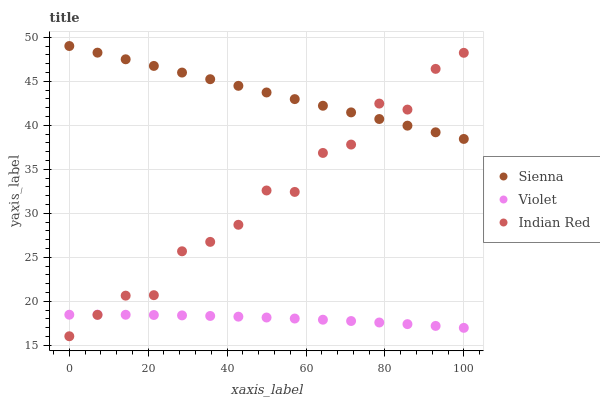Does Violet have the minimum area under the curve?
Answer yes or no. Yes. Does Sienna have the maximum area under the curve?
Answer yes or no. Yes. Does Indian Red have the minimum area under the curve?
Answer yes or no. No. Does Indian Red have the maximum area under the curve?
Answer yes or no. No. Is Sienna the smoothest?
Answer yes or no. Yes. Is Indian Red the roughest?
Answer yes or no. Yes. Is Violet the smoothest?
Answer yes or no. No. Is Violet the roughest?
Answer yes or no. No. Does Indian Red have the lowest value?
Answer yes or no. Yes. Does Violet have the lowest value?
Answer yes or no. No. Does Sienna have the highest value?
Answer yes or no. Yes. Does Indian Red have the highest value?
Answer yes or no. No. Is Violet less than Sienna?
Answer yes or no. Yes. Is Sienna greater than Violet?
Answer yes or no. Yes. Does Violet intersect Indian Red?
Answer yes or no. Yes. Is Violet less than Indian Red?
Answer yes or no. No. Is Violet greater than Indian Red?
Answer yes or no. No. Does Violet intersect Sienna?
Answer yes or no. No. 